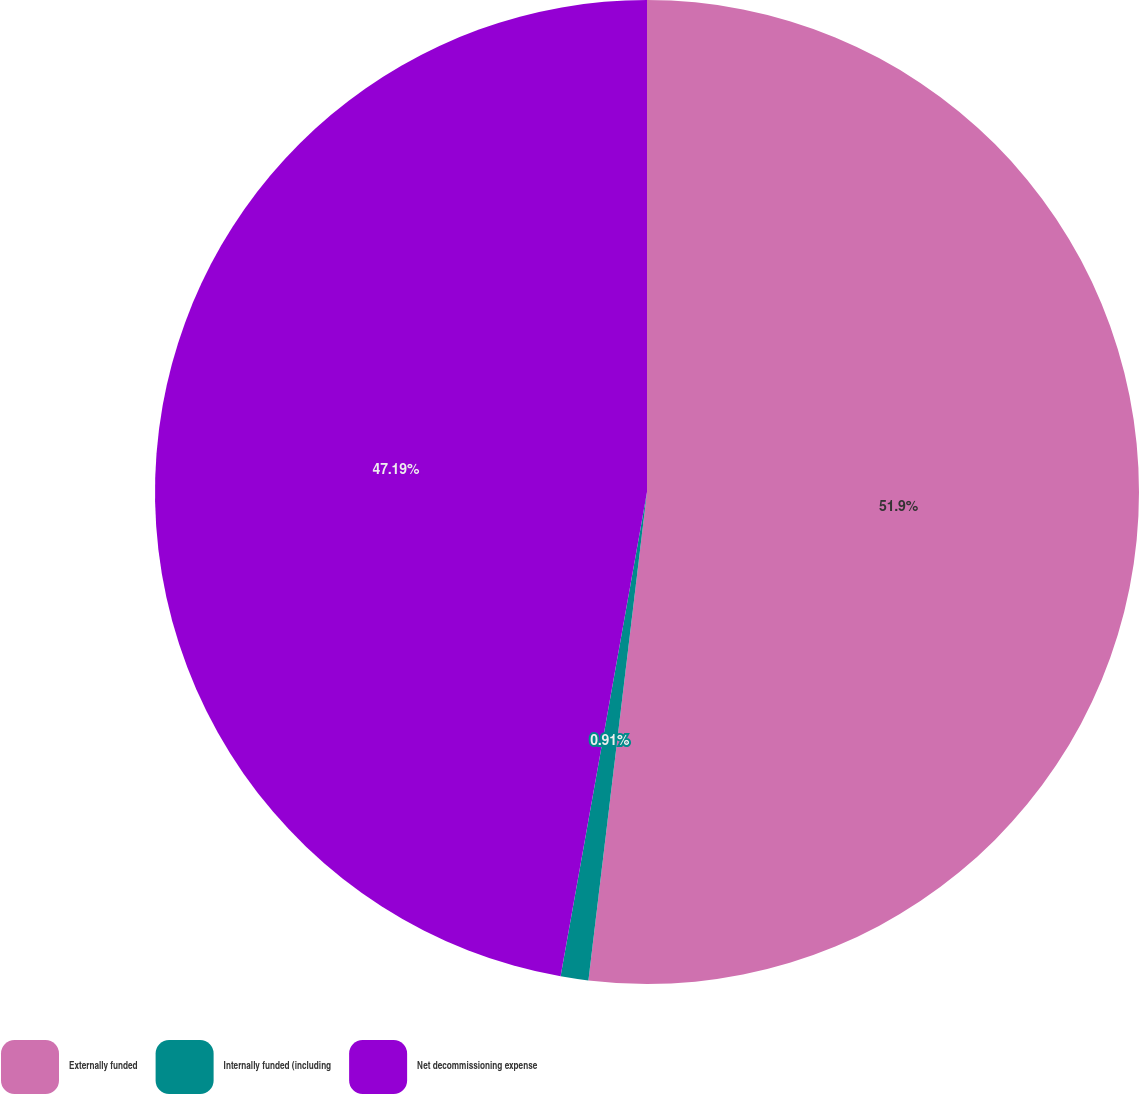<chart> <loc_0><loc_0><loc_500><loc_500><pie_chart><fcel>Externally funded<fcel>Internally funded (including<fcel>Net decommissioning expense<nl><fcel>51.9%<fcel>0.91%<fcel>47.19%<nl></chart> 